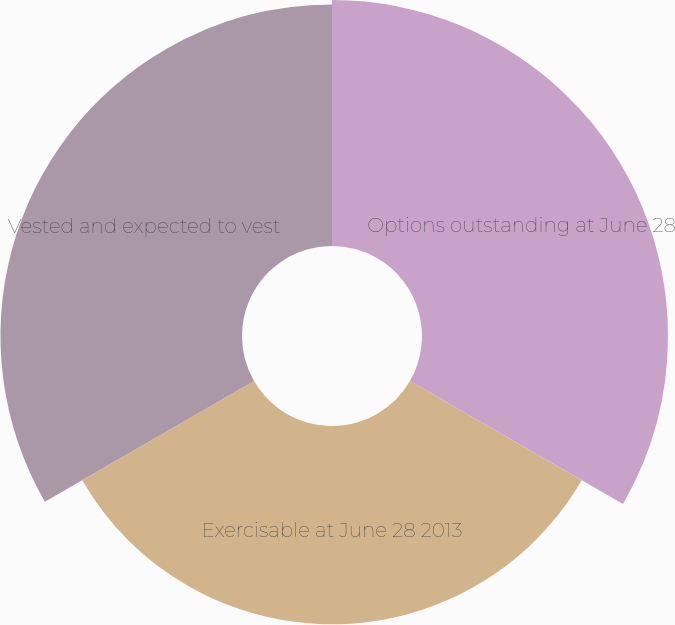Convert chart to OTSL. <chart><loc_0><loc_0><loc_500><loc_500><pie_chart><fcel>Options outstanding at June 28<fcel>Exercisable at June 28 2013<fcel>Vested and expected to vest<nl><fcel>35.87%<fcel>28.92%<fcel>35.22%<nl></chart> 